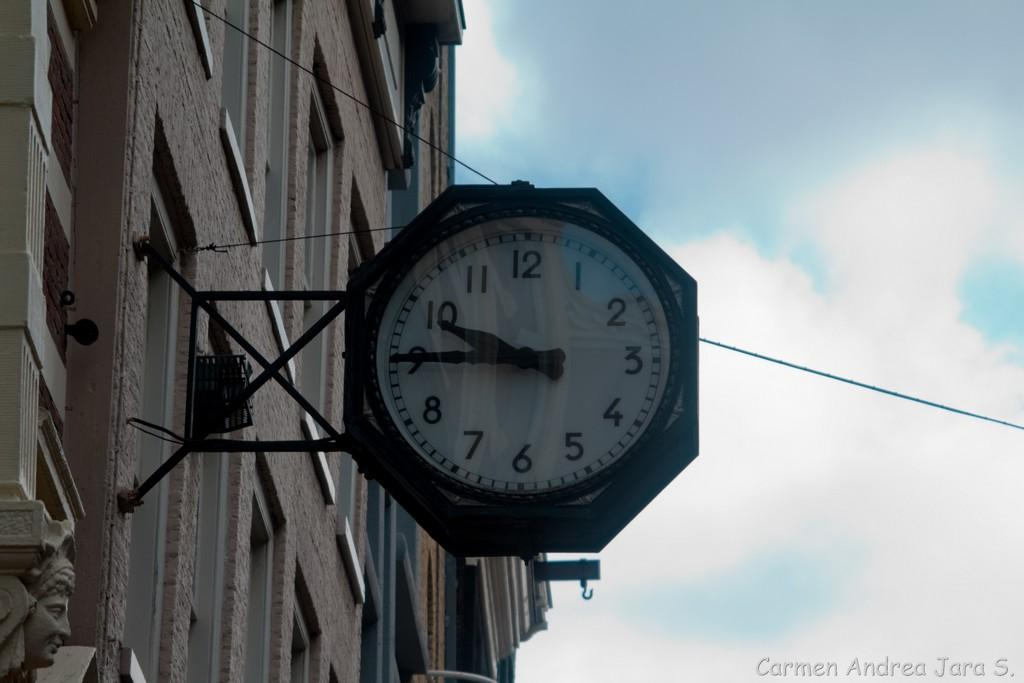<image>
Offer a succinct explanation of the picture presented. The time is 9:45 on a clock on the side of a building. 